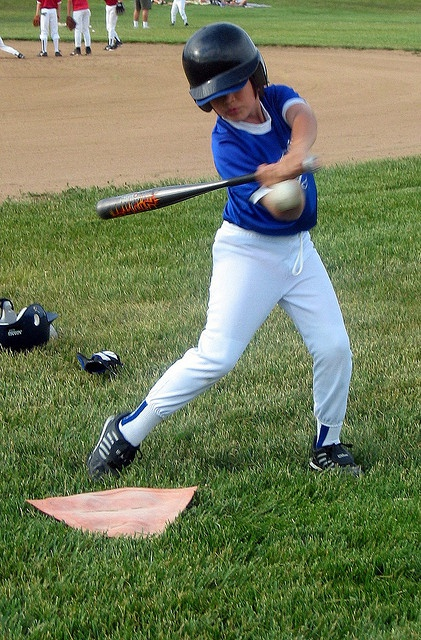Describe the objects in this image and their specific colors. I can see people in olive, white, lightblue, and black tones, baseball bat in olive, black, darkgray, gray, and lightgray tones, sports ball in olive, lightgray, darkgray, gray, and black tones, people in olive, lightgray, darkgray, and gray tones, and people in olive, lavender, darkgray, and maroon tones in this image. 